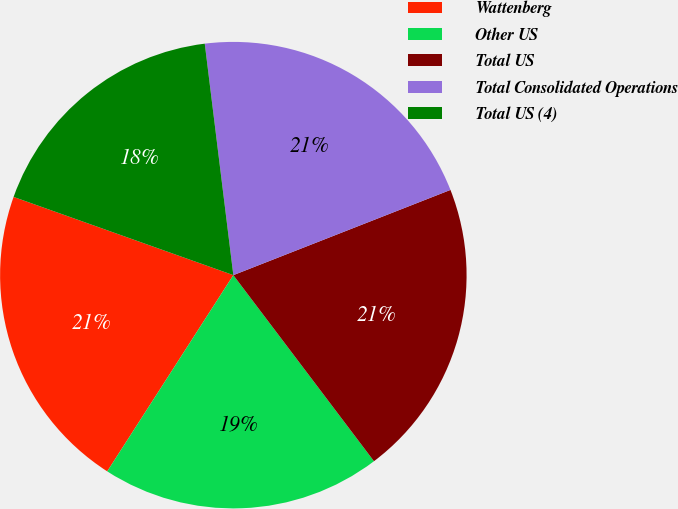<chart> <loc_0><loc_0><loc_500><loc_500><pie_chart><fcel>Wattenberg<fcel>Other US<fcel>Total US<fcel>Total Consolidated Operations<fcel>Total US (4)<nl><fcel>21.35%<fcel>19.39%<fcel>20.65%<fcel>21.0%<fcel>17.6%<nl></chart> 